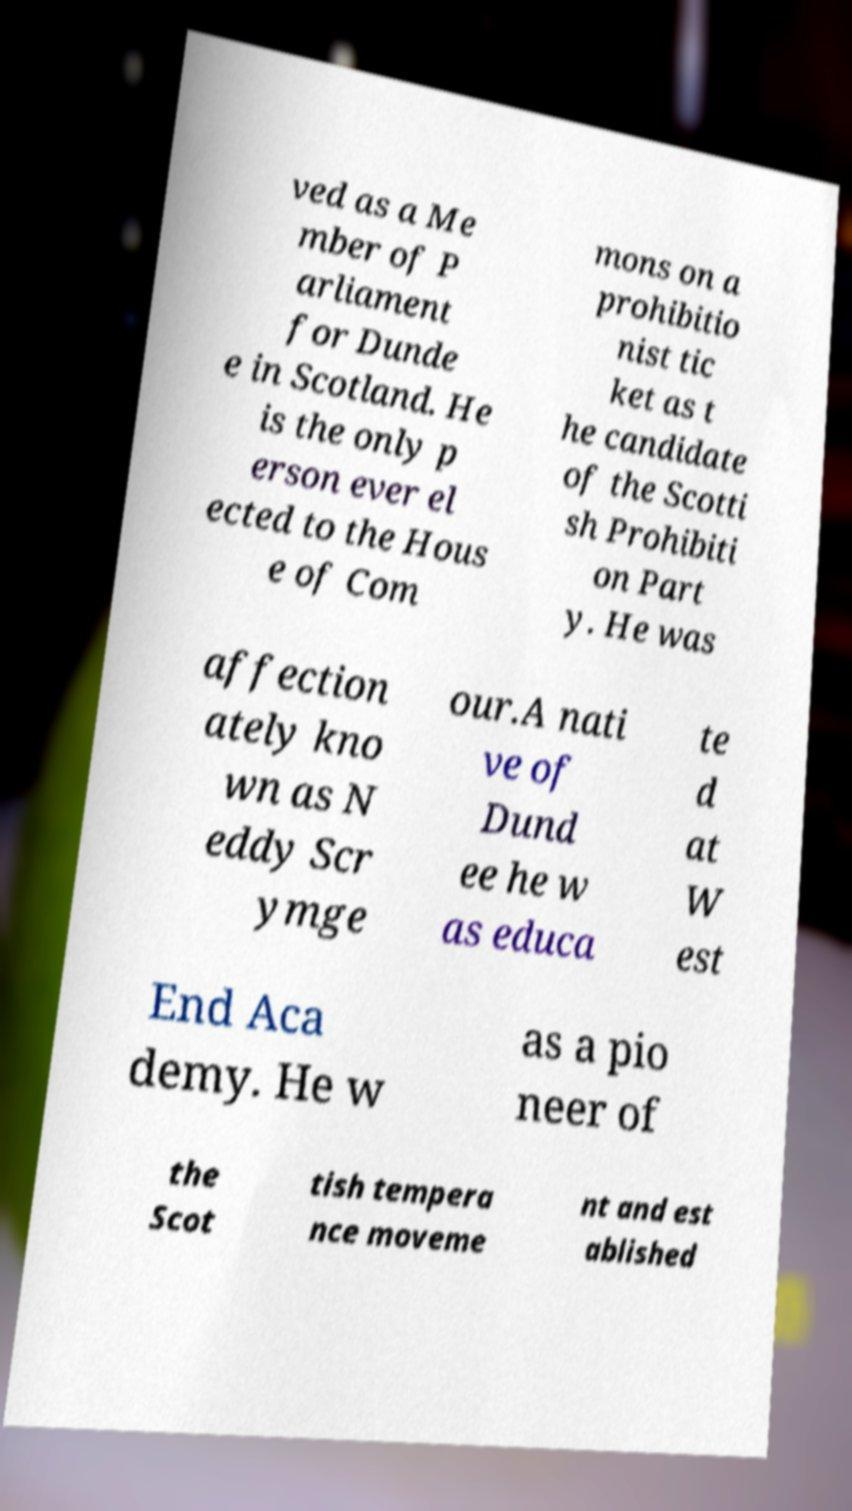I need the written content from this picture converted into text. Can you do that? ved as a Me mber of P arliament for Dunde e in Scotland. He is the only p erson ever el ected to the Hous e of Com mons on a prohibitio nist tic ket as t he candidate of the Scotti sh Prohibiti on Part y. He was affection ately kno wn as N eddy Scr ymge our.A nati ve of Dund ee he w as educa te d at W est End Aca demy. He w as a pio neer of the Scot tish tempera nce moveme nt and est ablished 